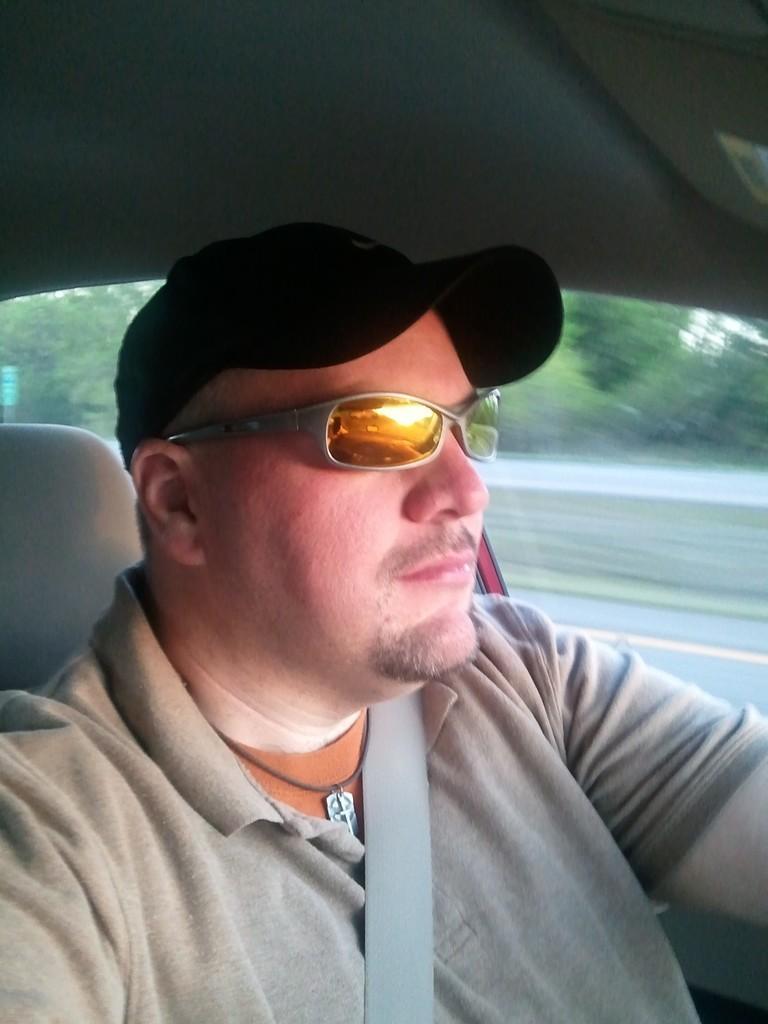Can you describe this image briefly? In this image we can see a person is wearing a cap, specs and ash color shirt. He wore seat belts and sitting in a car. 